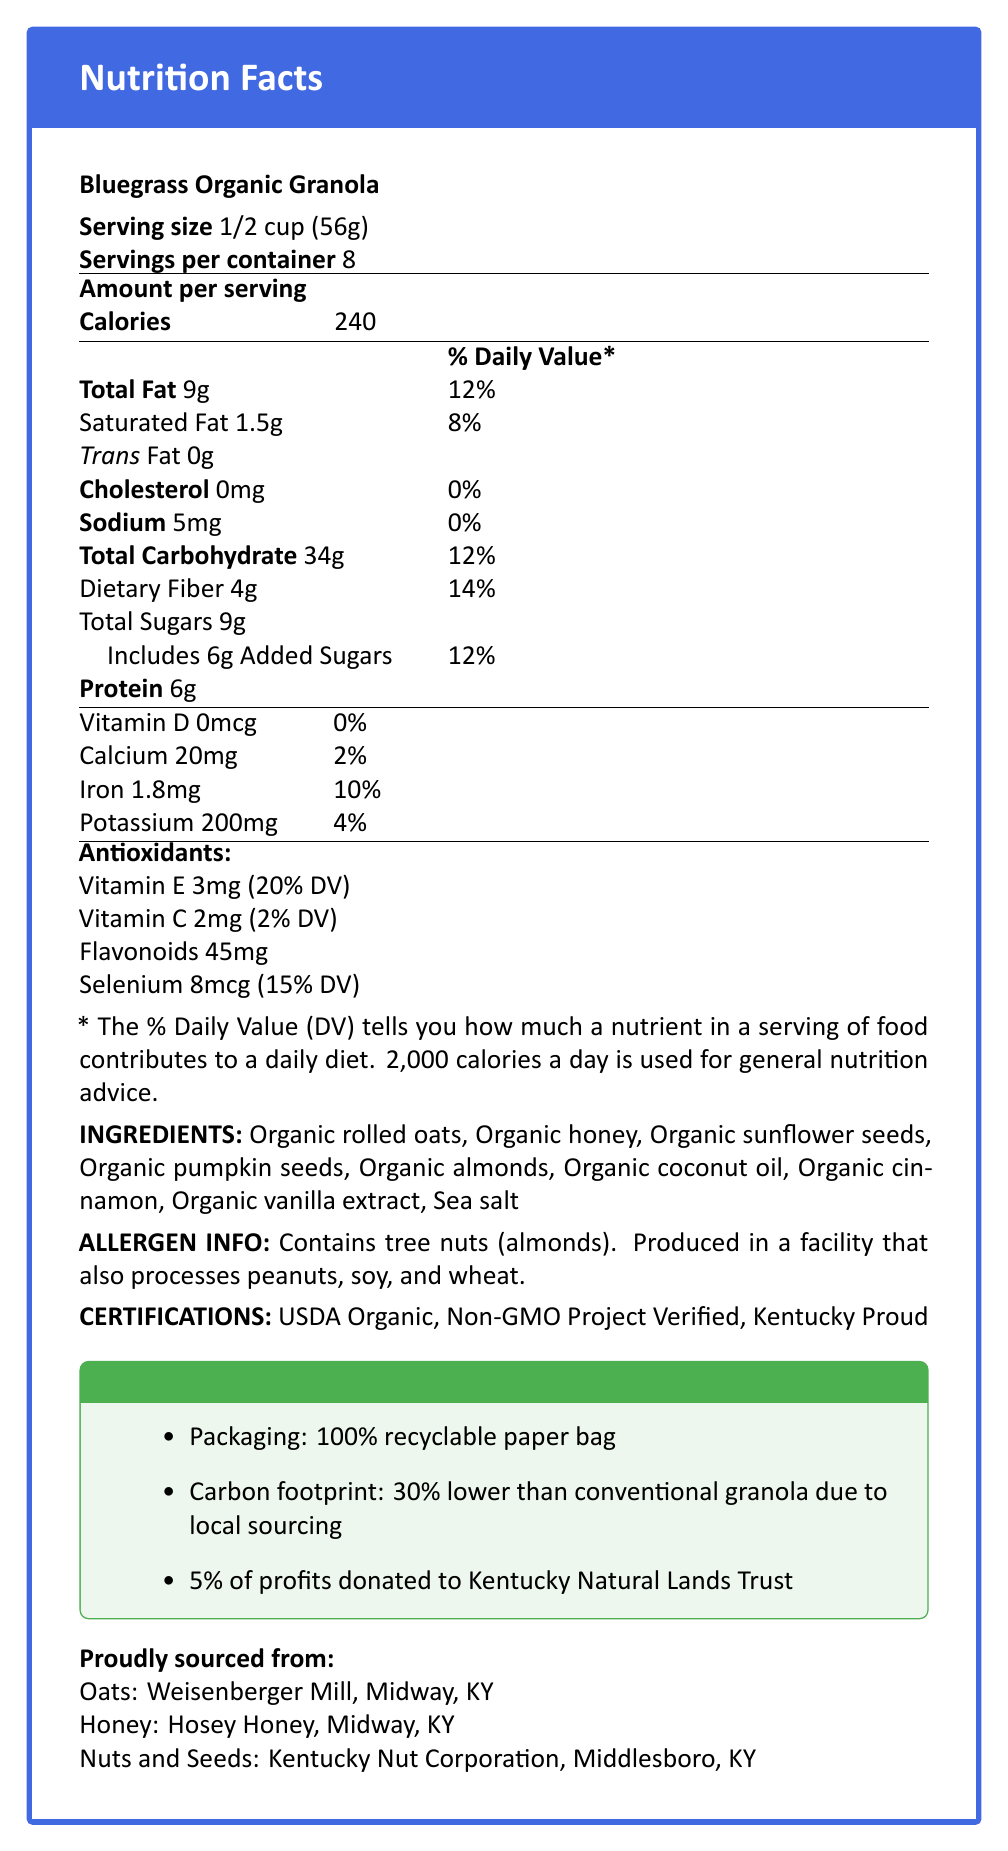What is the serving size for Bluegrass Organic Granola? The serving size is stated near the top of the document, right after the product name.
Answer: 1/2 cup (56g) How many servings are there per container? This information is provided right below the serving size, labeled as "Servings per container."
Answer: 8 What is the total fat content per serving, and how much of the daily value (DV) does it represent? The total fat content per serving is listed as "9g" with "12%" daily value.
Answer: 9g, 12% DV How much protein is in each serving? The amount of protein per serving is clearly stated in the main nutritional breakdown.
Answer: 6g How much dietary fiber does the granola contain per serving, and what is the corresponding daily value percentage? The dietary fiber content is listed as "4g" and has a daily value of "14%."
Answer: 4g, 14% DV Which ingredient is specified as an allergen? The allergen information mentions that the product contains tree nuts, specifying almonds.
Answer: Almonds Where is the honey sourced from? This sourcing information is given near the end of the document under "Proudly sourced from."
Answer: Hosey Honey, Midway, KY What percentage of the daily value for Vitamin E is provided per serving? The antioxidant section lists Vitamin E as providing "20% DV."
Answer: 20% How much selenium is present per serving, and what is its daily value percentage? The antioxidant section specifies selenium content as "8mcg" with a "15% DV."
Answer: 8mcg, 15% DV What is the total carbon footprint reduction for this product compared to conventional granola? The sustainability section mentions a "30% lower" carbon footprint due to local sourcing.
Answer: 30% lower How many grams of added sugars are in a serving of the granola? The total added sugars are listed as "6g" per serving in the nutrition facts.
Answer: 6g Which certification logos can be found on this granola product? A. USDA Organic and Non-GMO Project Verified B. Kentucky Proud and Gluten-Free C. Vegan and Kosher The certifications listed include "USDA Organic," "Non-GMO Project Verified," and "Kentucky Proud." Option A includes the relevant certifications.
Answer: A What amount of iron does each serving of granola provide? A. 1.8mg B. 20mg C. 8mcg The iron content per serving is "1.8mg" according to the nutrition facts.
Answer: A Does Bluegrass Organic Granola contain any trans fats? The document explicitly states "Trans Fat 0g."
Answer: No Summarize the entire document in one sentence. The document includes the product's name, serving details, nutritional facts, antioxidant breakdown, ingredients, allergen information, certifications, sourcing, and sustainability aspects.
Answer: The document provides comprehensive nutritional and sourcing information about locally-sourced Bluegrass Organic Granola, highlighting its health benefits,organic ingredients, and commitment to sustainability, including recyclable packaging and charitable contributions. What is the main ingredient used in Bluegrass Organic Granola? While the document lists all the ingredients, it does not specify which is the main ingredient.
Answer: Cannot be determined Does the granola contain any artificial ingredients or preservatives? The ingredients listed are all organic and do not include any artificial ingredients or preservatives.
Answer: No 